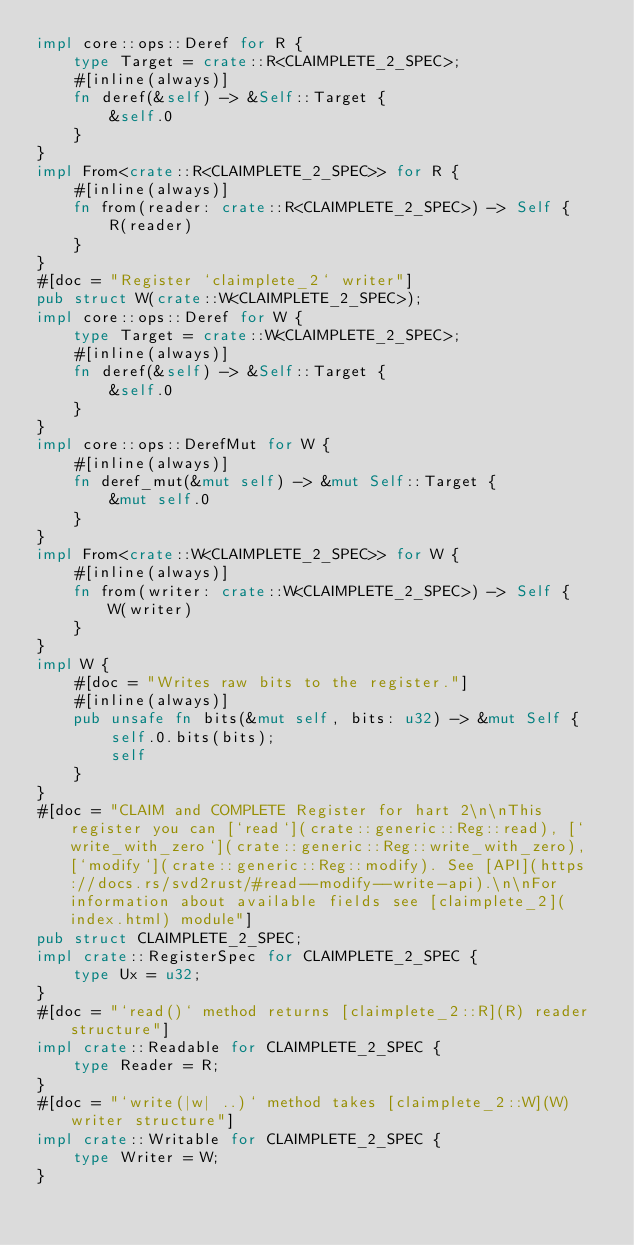Convert code to text. <code><loc_0><loc_0><loc_500><loc_500><_Rust_>impl core::ops::Deref for R {
    type Target = crate::R<CLAIMPLETE_2_SPEC>;
    #[inline(always)]
    fn deref(&self) -> &Self::Target {
        &self.0
    }
}
impl From<crate::R<CLAIMPLETE_2_SPEC>> for R {
    #[inline(always)]
    fn from(reader: crate::R<CLAIMPLETE_2_SPEC>) -> Self {
        R(reader)
    }
}
#[doc = "Register `claimplete_2` writer"]
pub struct W(crate::W<CLAIMPLETE_2_SPEC>);
impl core::ops::Deref for W {
    type Target = crate::W<CLAIMPLETE_2_SPEC>;
    #[inline(always)]
    fn deref(&self) -> &Self::Target {
        &self.0
    }
}
impl core::ops::DerefMut for W {
    #[inline(always)]
    fn deref_mut(&mut self) -> &mut Self::Target {
        &mut self.0
    }
}
impl From<crate::W<CLAIMPLETE_2_SPEC>> for W {
    #[inline(always)]
    fn from(writer: crate::W<CLAIMPLETE_2_SPEC>) -> Self {
        W(writer)
    }
}
impl W {
    #[doc = "Writes raw bits to the register."]
    #[inline(always)]
    pub unsafe fn bits(&mut self, bits: u32) -> &mut Self {
        self.0.bits(bits);
        self
    }
}
#[doc = "CLAIM and COMPLETE Register for hart 2\n\nThis register you can [`read`](crate::generic::Reg::read), [`write_with_zero`](crate::generic::Reg::write_with_zero), [`modify`](crate::generic::Reg::modify). See [API](https://docs.rs/svd2rust/#read--modify--write-api).\n\nFor information about available fields see [claimplete_2](index.html) module"]
pub struct CLAIMPLETE_2_SPEC;
impl crate::RegisterSpec for CLAIMPLETE_2_SPEC {
    type Ux = u32;
}
#[doc = "`read()` method returns [claimplete_2::R](R) reader structure"]
impl crate::Readable for CLAIMPLETE_2_SPEC {
    type Reader = R;
}
#[doc = "`write(|w| ..)` method takes [claimplete_2::W](W) writer structure"]
impl crate::Writable for CLAIMPLETE_2_SPEC {
    type Writer = W;
}
</code> 